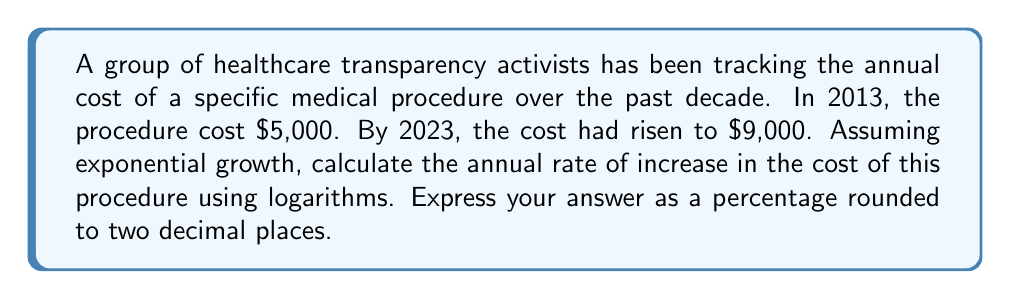Can you answer this question? To solve this problem, we'll use the exponential growth formula and logarithms:

1) The exponential growth formula is:
   $$A = P(1 + r)^t$$
   where A is the final amount, P is the initial amount, r is the annual growth rate, and t is the time in years.

2) Substituting our known values:
   $$9000 = 5000(1 + r)^{10}$$

3) Divide both sides by 5000:
   $$\frac{9000}{5000} = (1 + r)^{10}$$

4) Simplify:
   $$1.8 = (1 + r)^{10}$$

5) Take the natural logarithm of both sides:
   $$\ln(1.8) = \ln((1 + r)^{10})$$

6) Use the logarithm property $\ln(x^n) = n\ln(x)$:
   $$\ln(1.8) = 10\ln(1 + r)$$

7) Divide both sides by 10:
   $$\frac{\ln(1.8)}{10} = \ln(1 + r)$$

8) Apply the exponential function to both sides:
   $$e^{\frac{\ln(1.8)}{10}} = e^{\ln(1 + r)} = 1 + r$$

9) Subtract 1 from both sides:
   $$e^{\frac{\ln(1.8)}{10}} - 1 = r$$

10) Calculate the value:
    $$r \approx 0.0606 = 6.06\%$$

Therefore, the annual rate of increase is approximately 6.06%.
Answer: 6.06% 